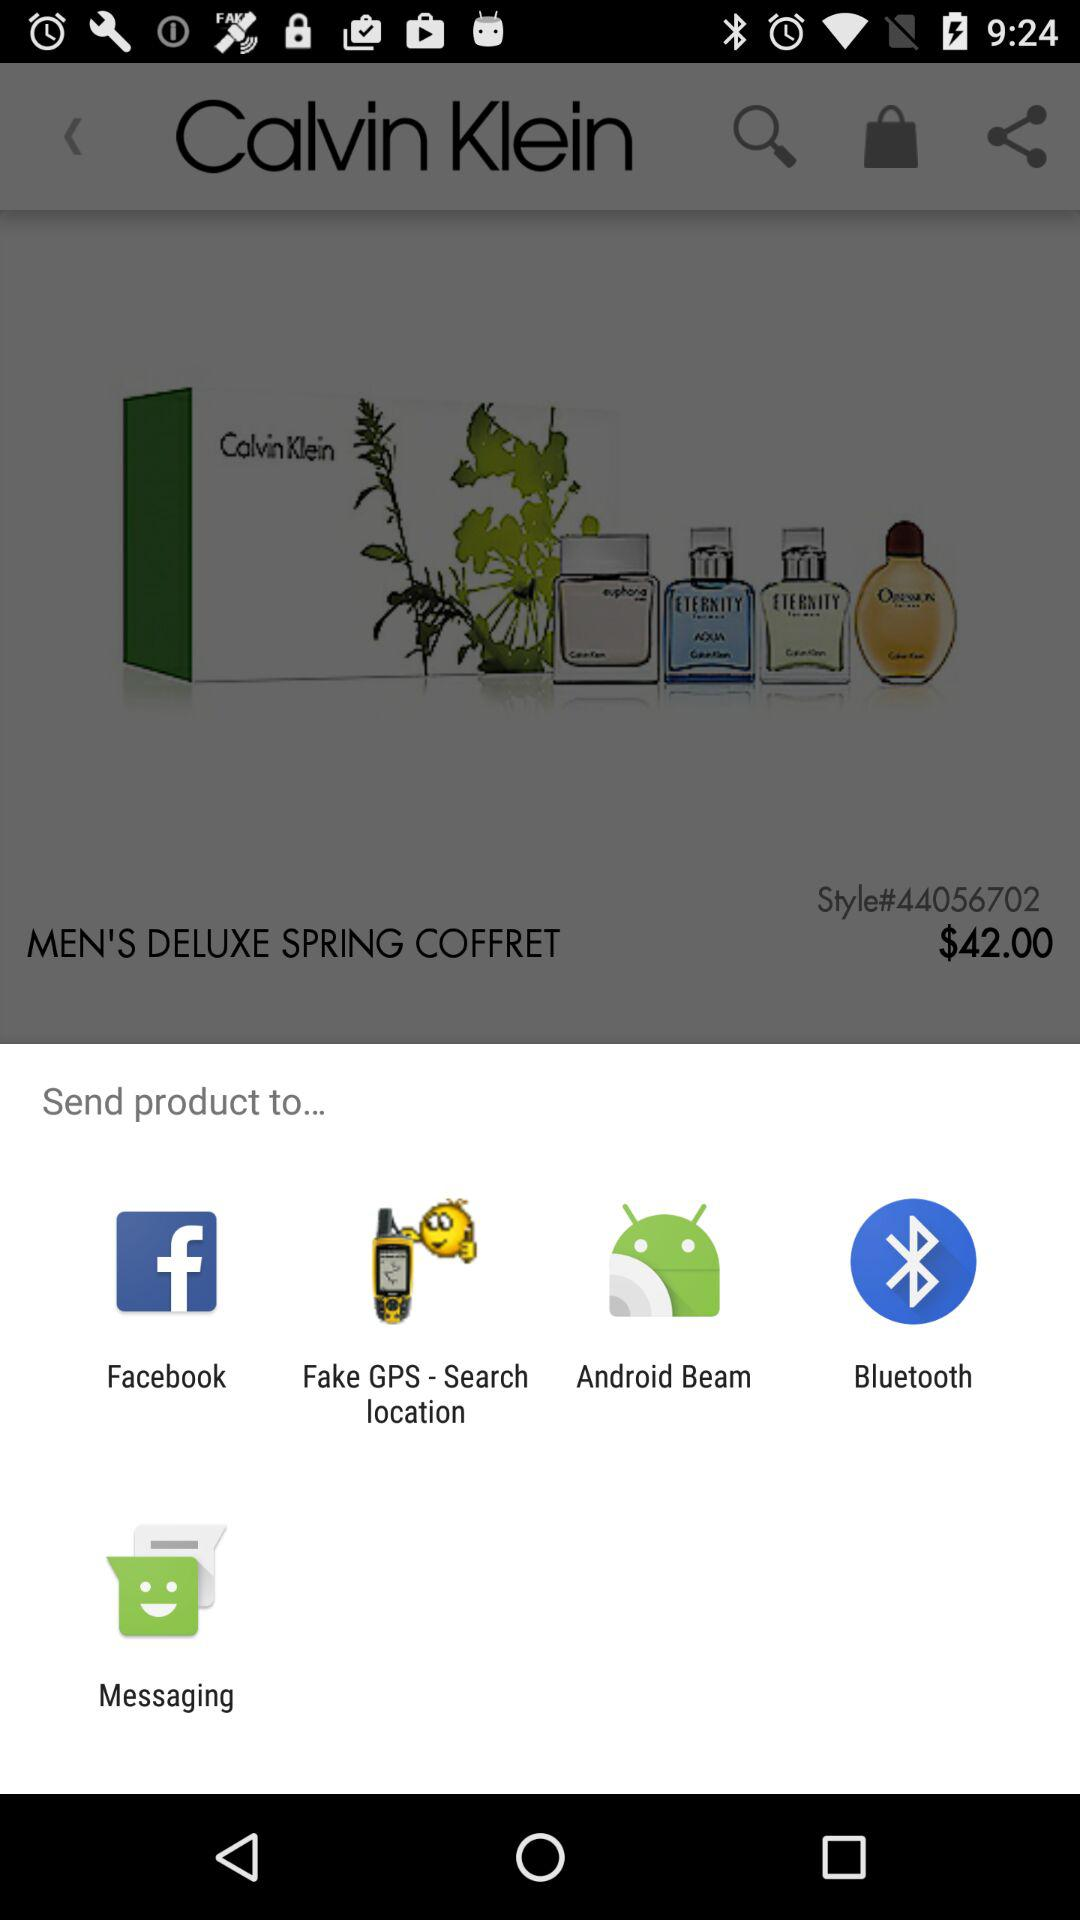Through what application can be sent? It can be sent through "Facebook", "Fake GPS - Search location", "Android Beam", "Bluetooth" and "Messaging". 